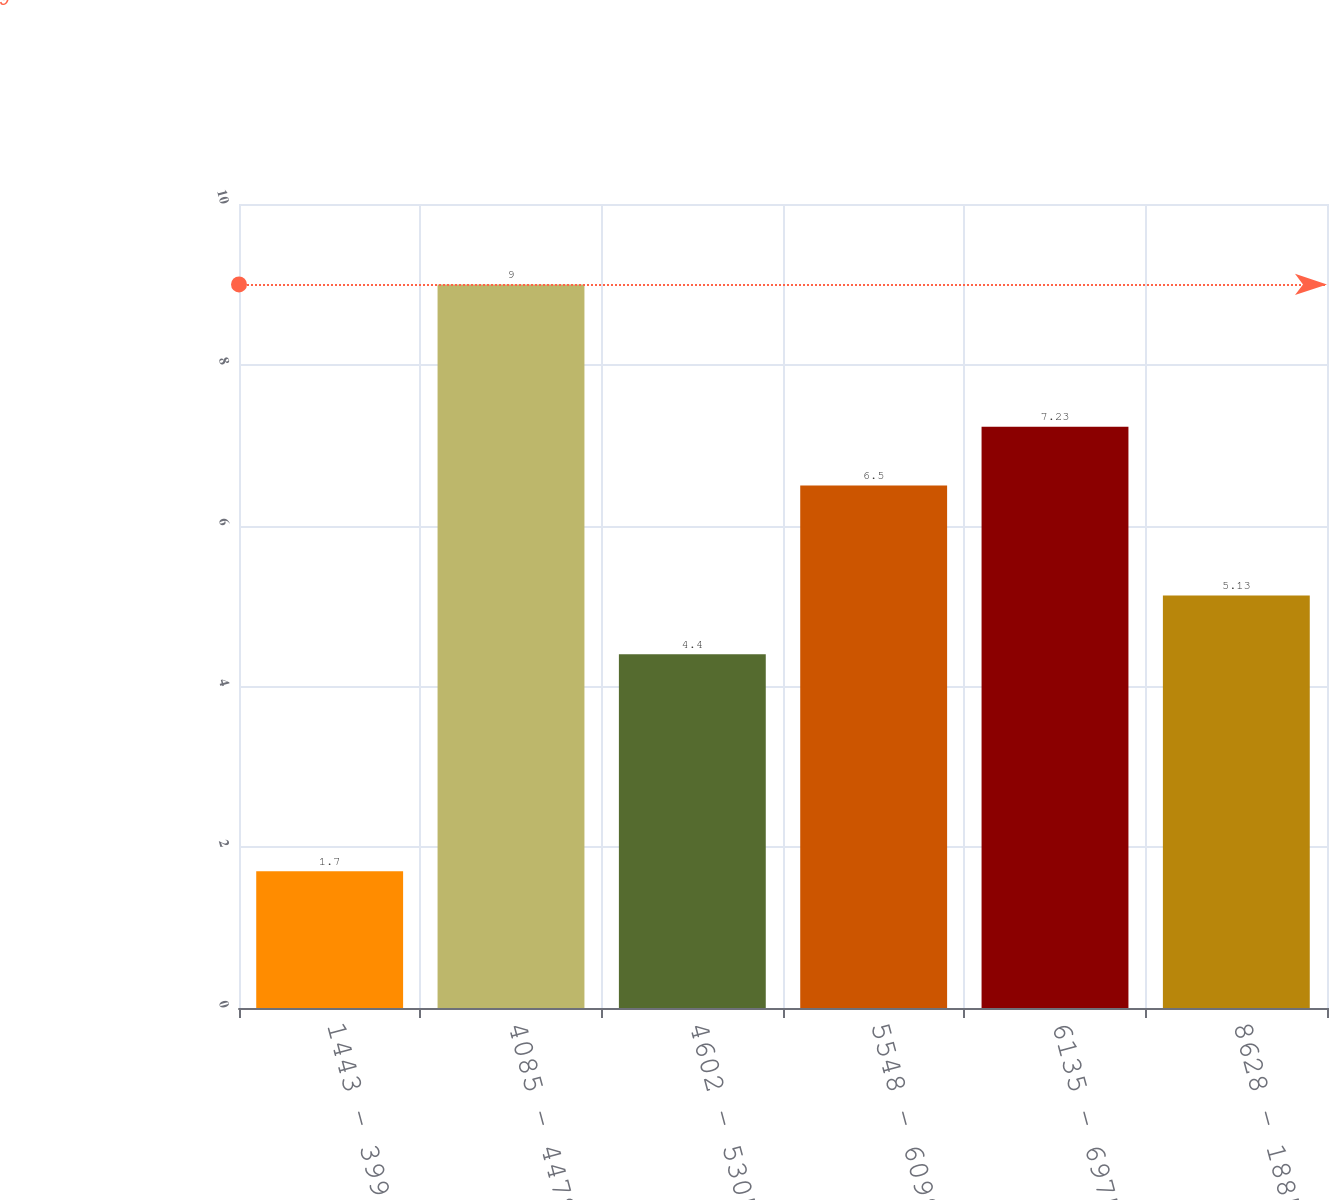Convert chart to OTSL. <chart><loc_0><loc_0><loc_500><loc_500><bar_chart><fcel>1443 - 3994<fcel>4085 - 4478<fcel>4602 - 5305<fcel>5548 - 6099<fcel>6135 - 6975<fcel>8628 - 18853<nl><fcel>1.7<fcel>9<fcel>4.4<fcel>6.5<fcel>7.23<fcel>5.13<nl></chart> 